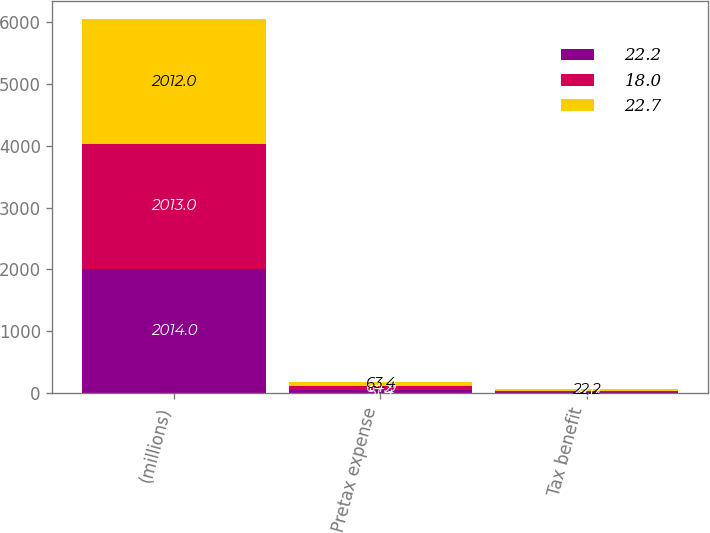<chart> <loc_0><loc_0><loc_500><loc_500><stacked_bar_chart><ecel><fcel>(millions)<fcel>Pretax expense<fcel>Tax benefit<nl><fcel>22.2<fcel>2014<fcel>51.4<fcel>18<nl><fcel>18<fcel>2013<fcel>64.9<fcel>22.7<nl><fcel>22.7<fcel>2012<fcel>63.4<fcel>22.2<nl></chart> 